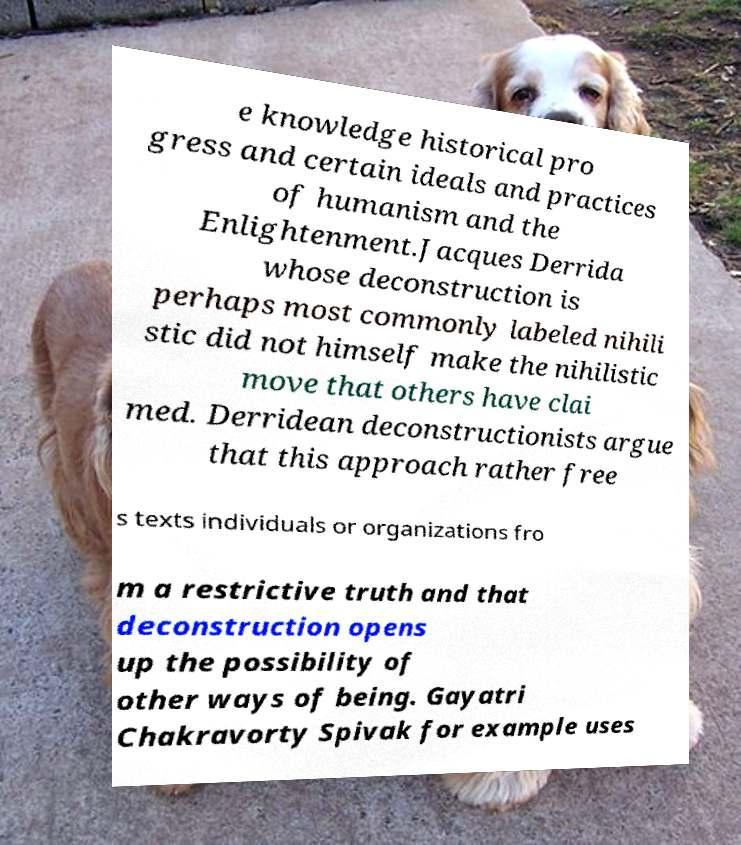Please read and relay the text visible in this image. What does it say? e knowledge historical pro gress and certain ideals and practices of humanism and the Enlightenment.Jacques Derrida whose deconstruction is perhaps most commonly labeled nihili stic did not himself make the nihilistic move that others have clai med. Derridean deconstructionists argue that this approach rather free s texts individuals or organizations fro m a restrictive truth and that deconstruction opens up the possibility of other ways of being. Gayatri Chakravorty Spivak for example uses 